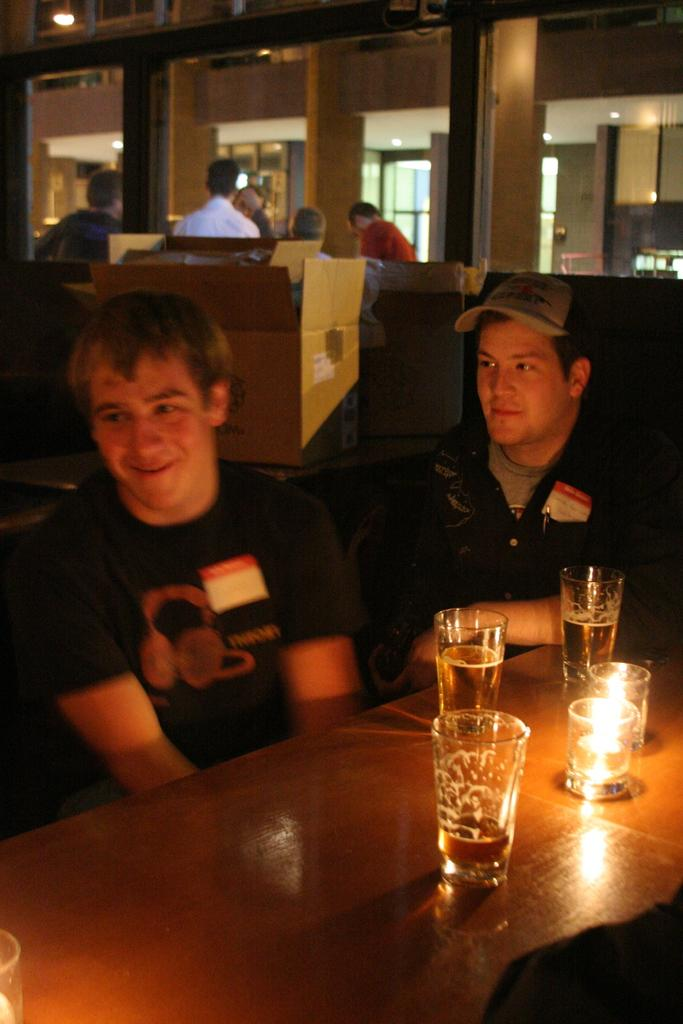How many people are in the image? There is a group of people in the image. What objects can be seen on the table in the image? There is a cardboard, a glass, and a candle on the table in the image. What type of bell can be heard ringing in the image? There is no bell present in the image, so it cannot be heard ringing. 